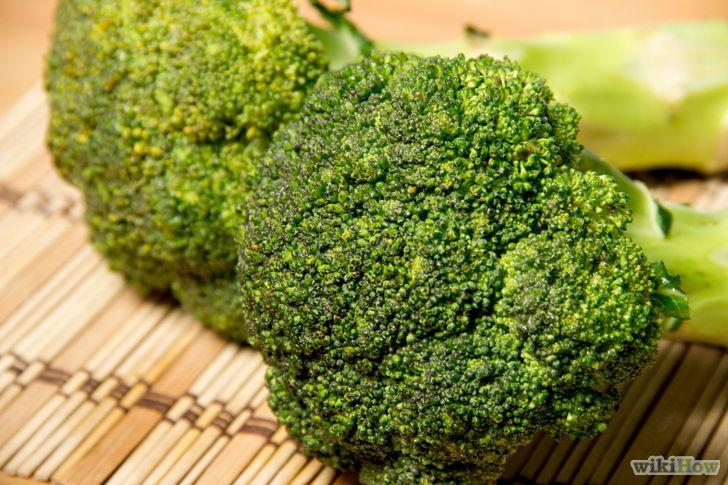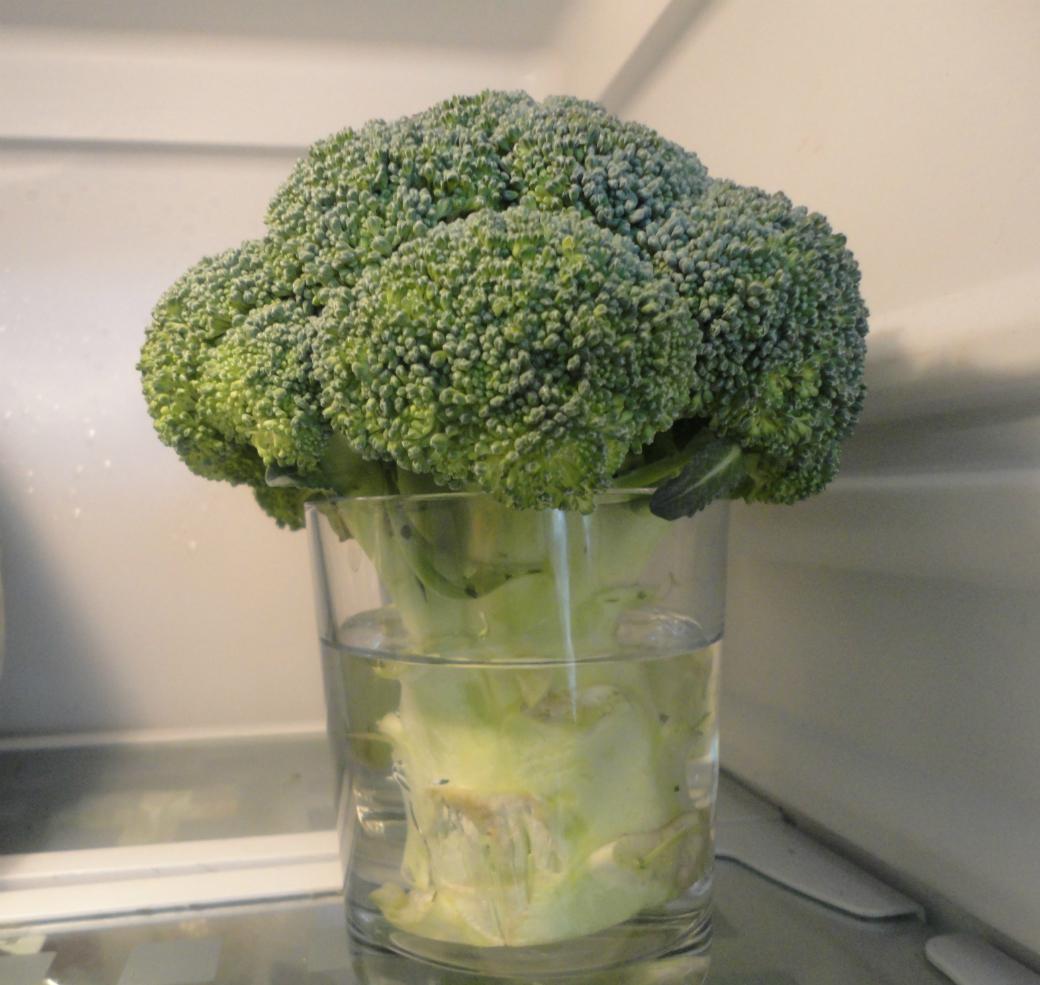The first image is the image on the left, the second image is the image on the right. Analyze the images presented: Is the assertion "The right image shows a stalk of broccoli inside of a cup." valid? Answer yes or no. Yes. 